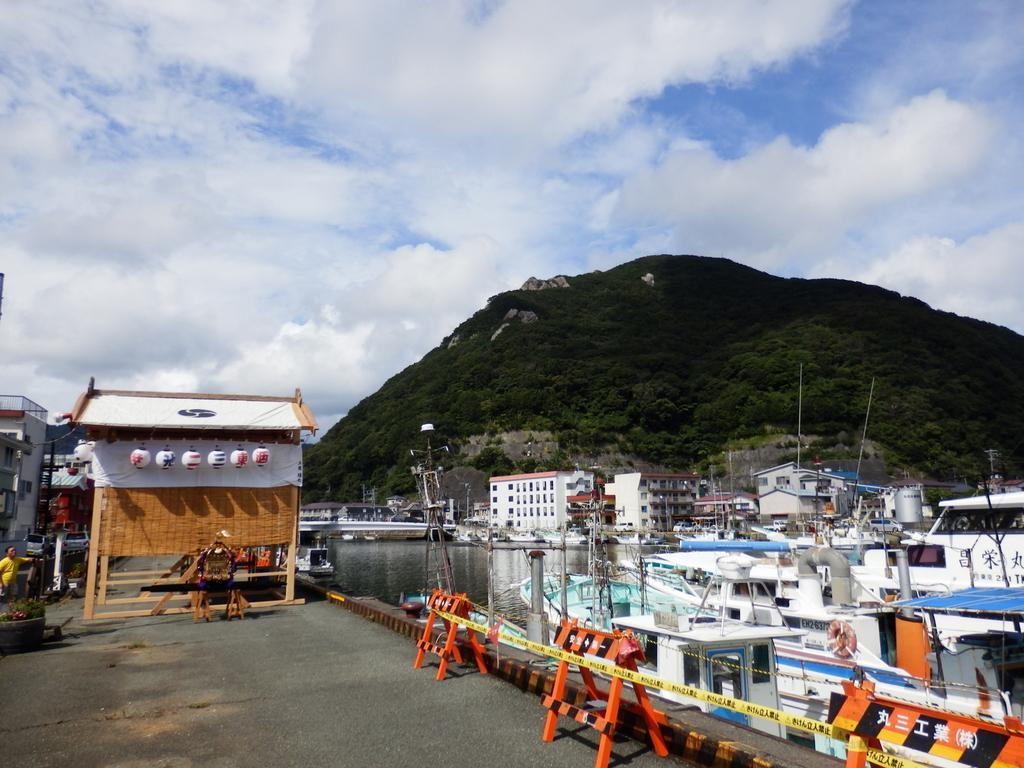What is in the water in the image? There are boats in the water in the image. What can be seen in the background of the image? There are trees, barricades, buildings, and the sky visible in the background. Can you describe the setting of the image? The image features boats in the water, with various structures and natural elements in the background. What type of flower is being distributed by the coach in the image? There is no coach or flower present in the image. 